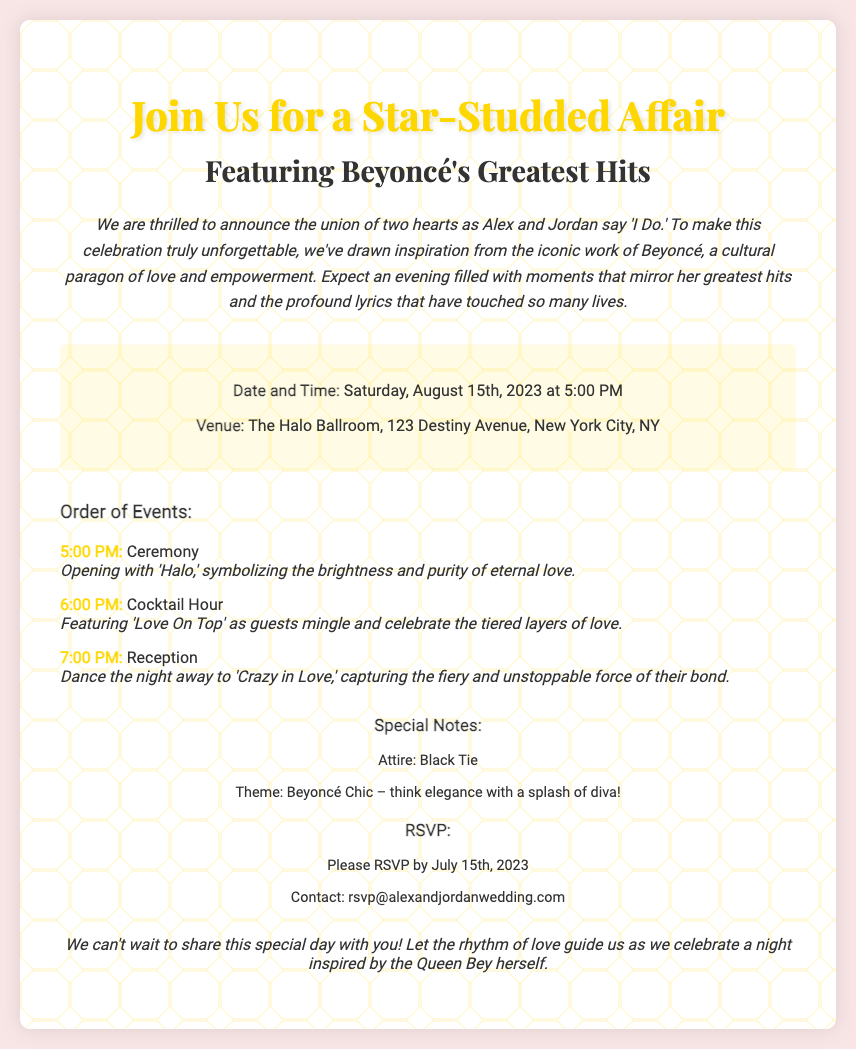What are the names of the couple? The invitation states "the union of two hearts as Alex and Jordan say 'I Do.'"
Answer: Alex and Jordan What is the date of the wedding? The invitation specifies "Saturday, August 15th, 2023 at 5:00 PM."
Answer: August 15th, 2023 What venue will the wedding take place? It mentions "The Halo Ballroom, 123 Destiny Avenue, New York City, NY."
Answer: The Halo Ballroom Which song opens the ceremony? It notes "Opening with 'Halo,' symbolizing the brightness and purity of eternal love."
Answer: Halo What theme is suggested for the attire? The document includes "Theme: Beyoncé Chic – think elegance with a splash of diva!"
Answer: Beyoncé Chic How should guests RSVP by? It indicates "Please RSVP by July 15th, 2023."
Answer: July 15th, 2023 What is a special note about the attire? It specifies "Attire: Black Tie."
Answer: Black Tie What time does the reception begin? The invitation states "7:00 PM: Reception."
Answer: 7:00 PM What is the last line of the closing? The closing states "Let the rhythm of love guide us as we celebrate a night inspired by the Queen Bey herself."
Answer: inspired by the Queen Bey herself 